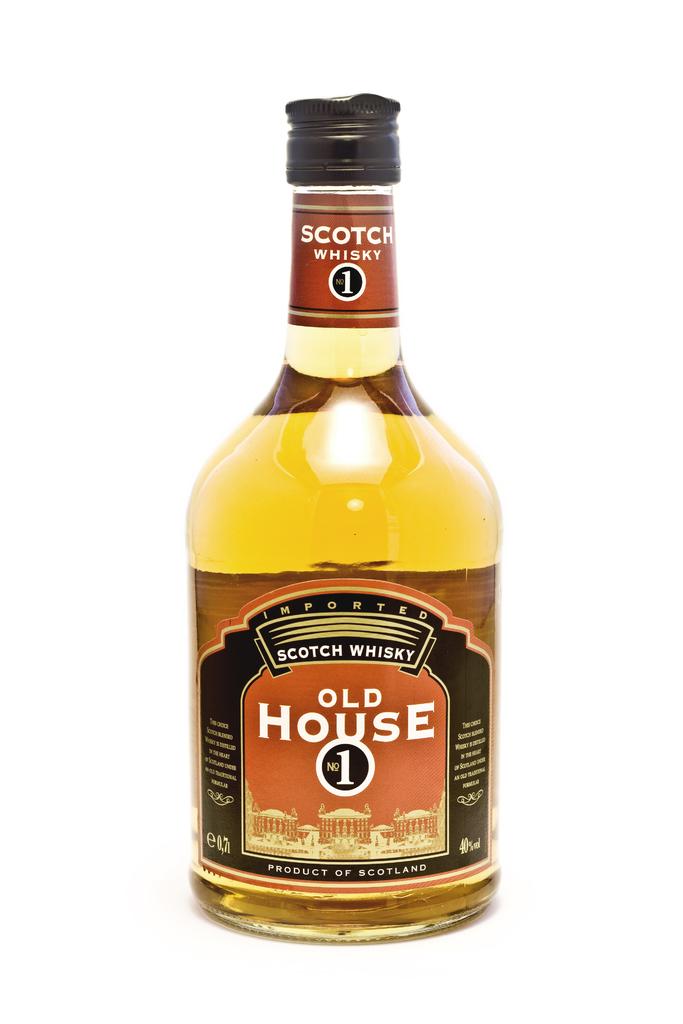What type of whiskey is in this bottle?
Offer a very short reply. Scotch. Is this made by old house?
Provide a short and direct response. Yes. 